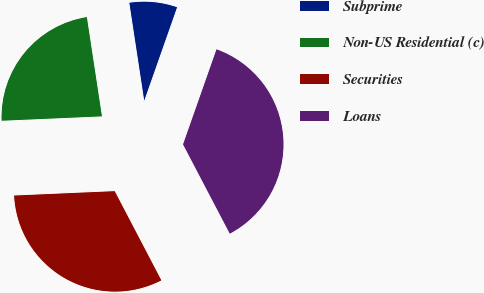Convert chart. <chart><loc_0><loc_0><loc_500><loc_500><pie_chart><fcel>Subprime<fcel>Non-US Residential (c)<fcel>Securities<fcel>Loans<nl><fcel>7.79%<fcel>23.29%<fcel>31.98%<fcel>36.94%<nl></chart> 